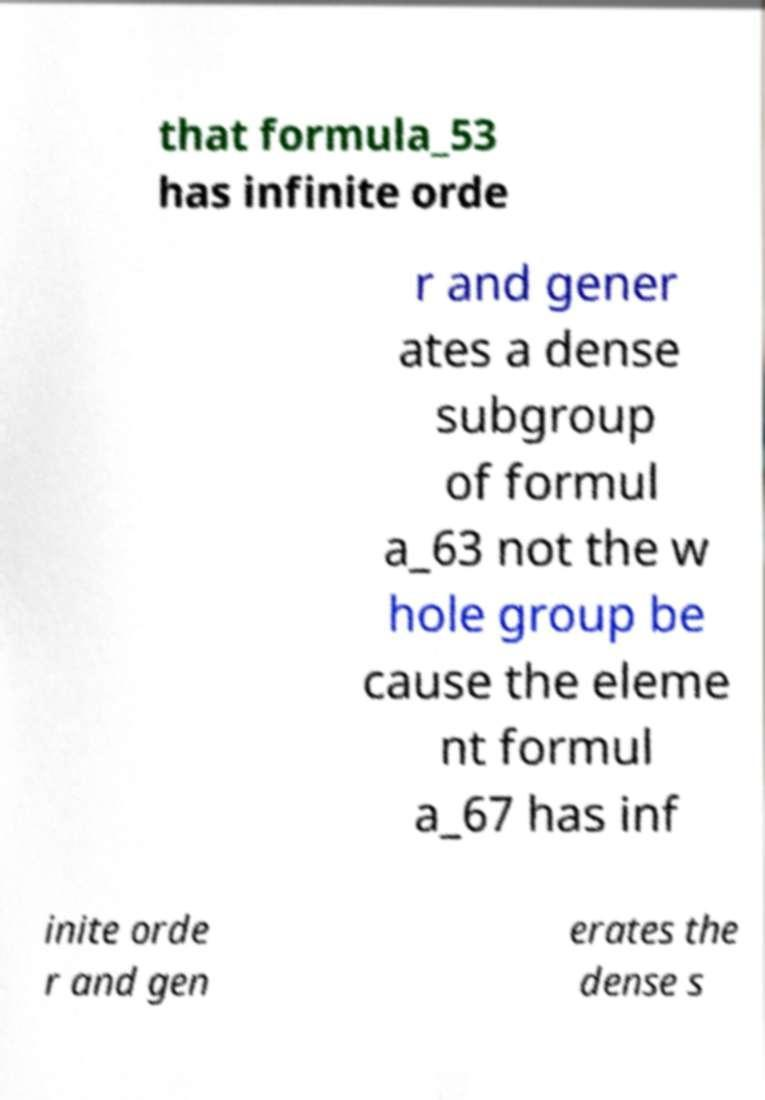Can you accurately transcribe the text from the provided image for me? that formula_53 has infinite orde r and gener ates a dense subgroup of formul a_63 not the w hole group be cause the eleme nt formul a_67 has inf inite orde r and gen erates the dense s 